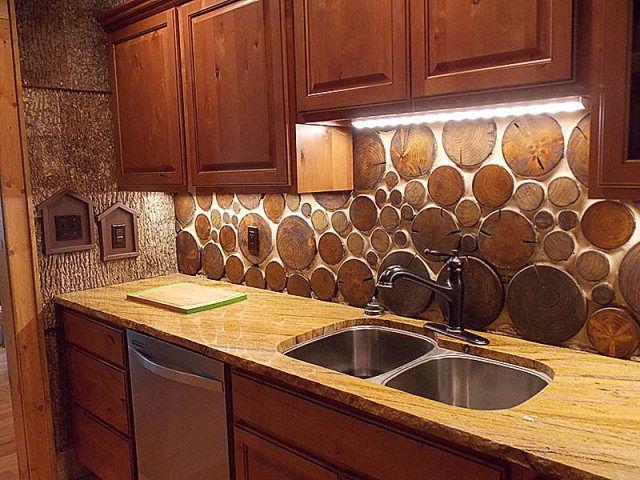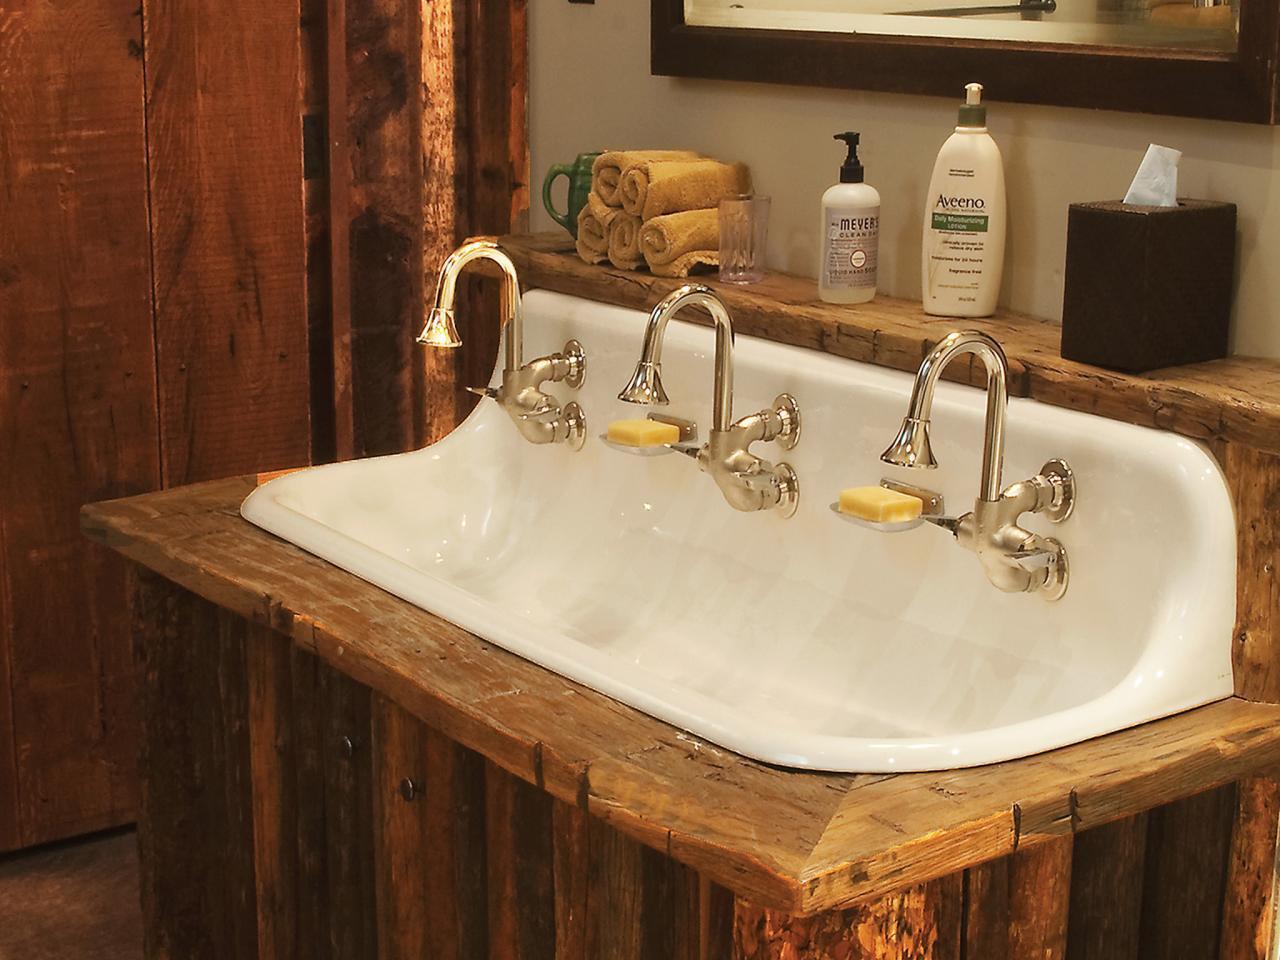The first image is the image on the left, the second image is the image on the right. For the images displayed, is the sentence "A white sink on a wooden vanity angles up at the back to form its own backsplash and has chrome faucets with bell-shaped ends." factually correct? Answer yes or no. Yes. The first image is the image on the left, the second image is the image on the right. Evaluate the accuracy of this statement regarding the images: "A mirror sits above the sink in the image on the left.". Is it true? Answer yes or no. No. 